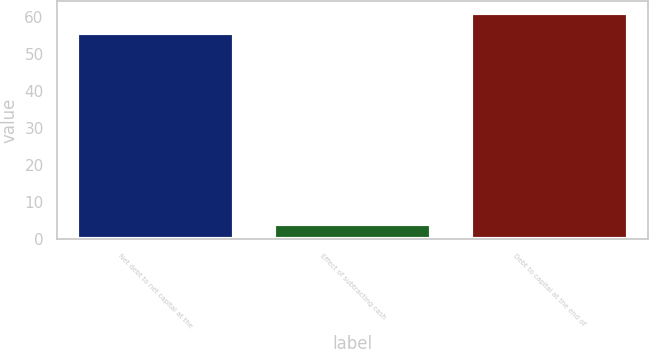Convert chart to OTSL. <chart><loc_0><loc_0><loc_500><loc_500><bar_chart><fcel>Net debt to net capital at the<fcel>Effect of subtracting cash<fcel>Debt to capital at the end of<nl><fcel>55.6<fcel>4.1<fcel>61.16<nl></chart> 